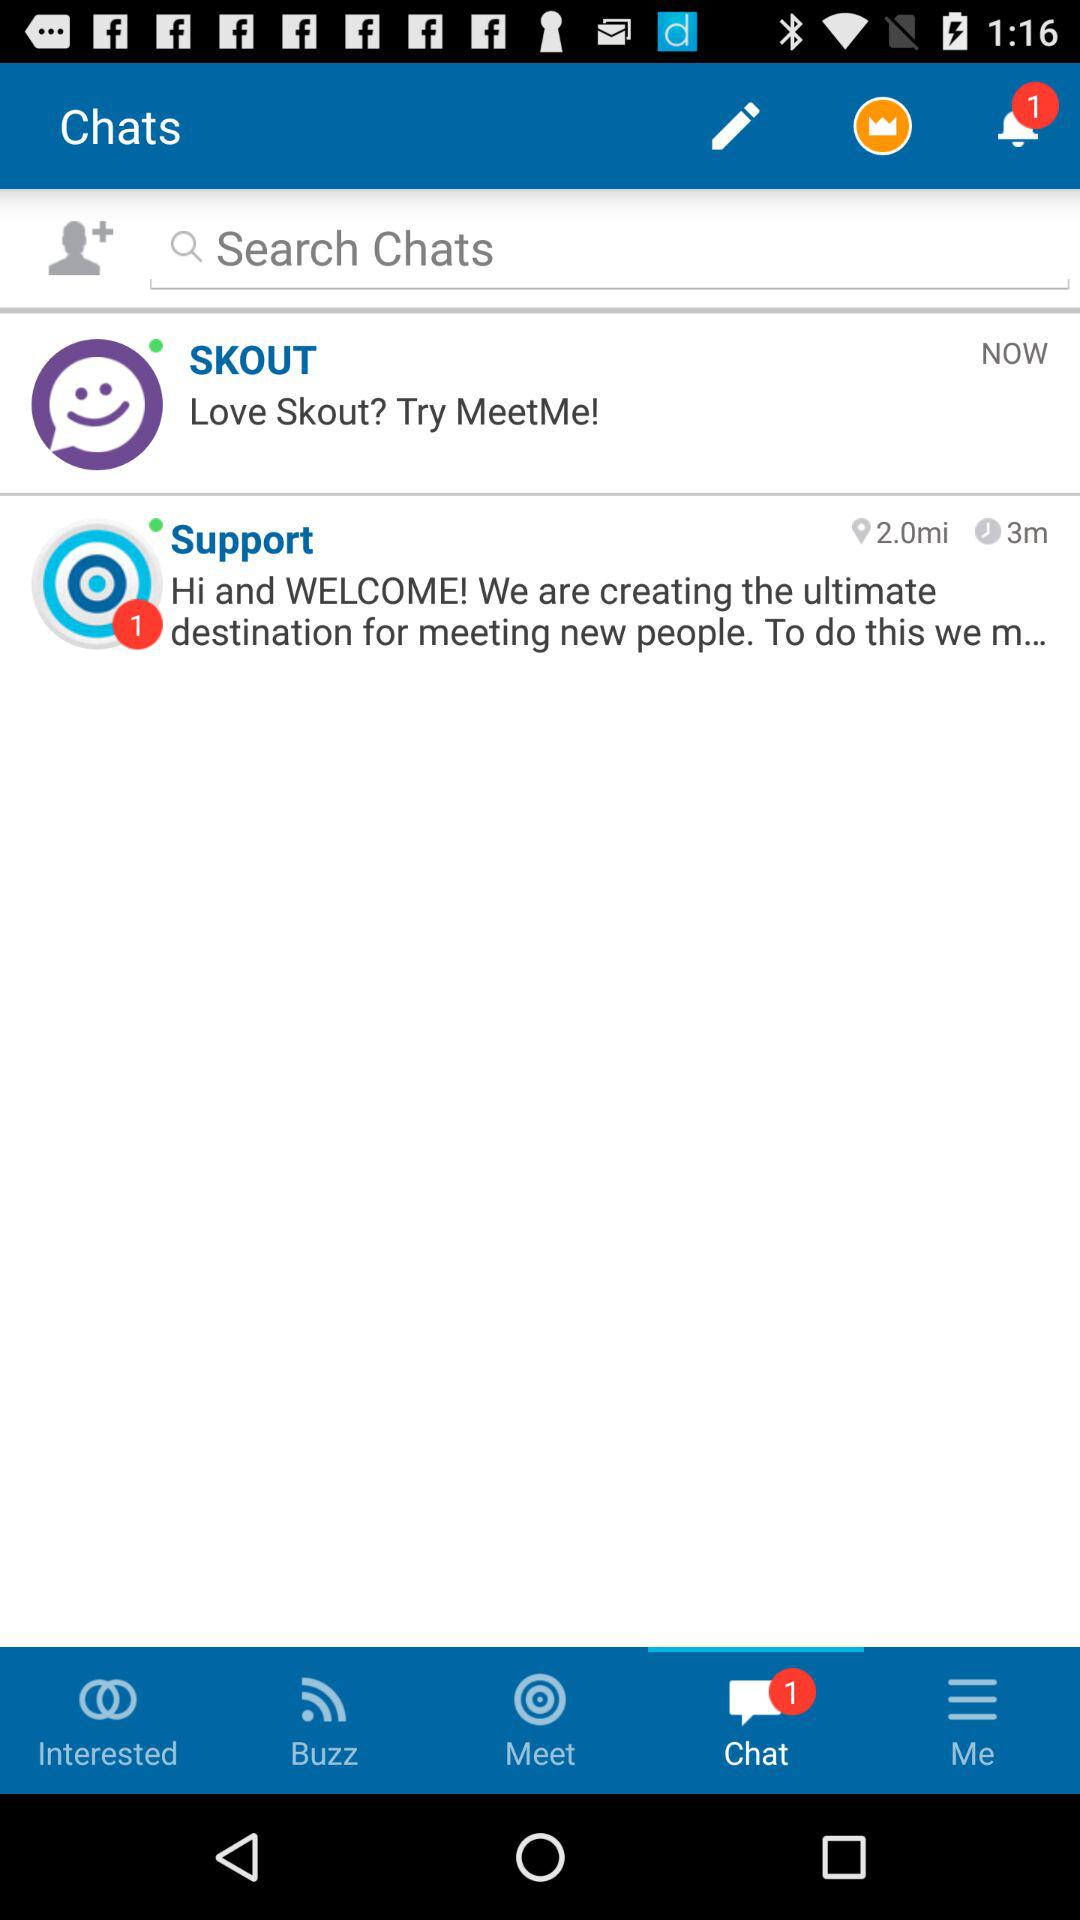What is the time duration?
When the provided information is insufficient, respond with <no answer>. <no answer> 